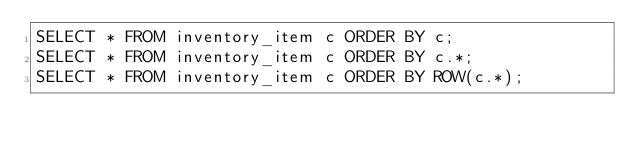<code> <loc_0><loc_0><loc_500><loc_500><_SQL_>SELECT * FROM inventory_item c ORDER BY c;
SELECT * FROM inventory_item c ORDER BY c.*;
SELECT * FROM inventory_item c ORDER BY ROW(c.*);
</code> 